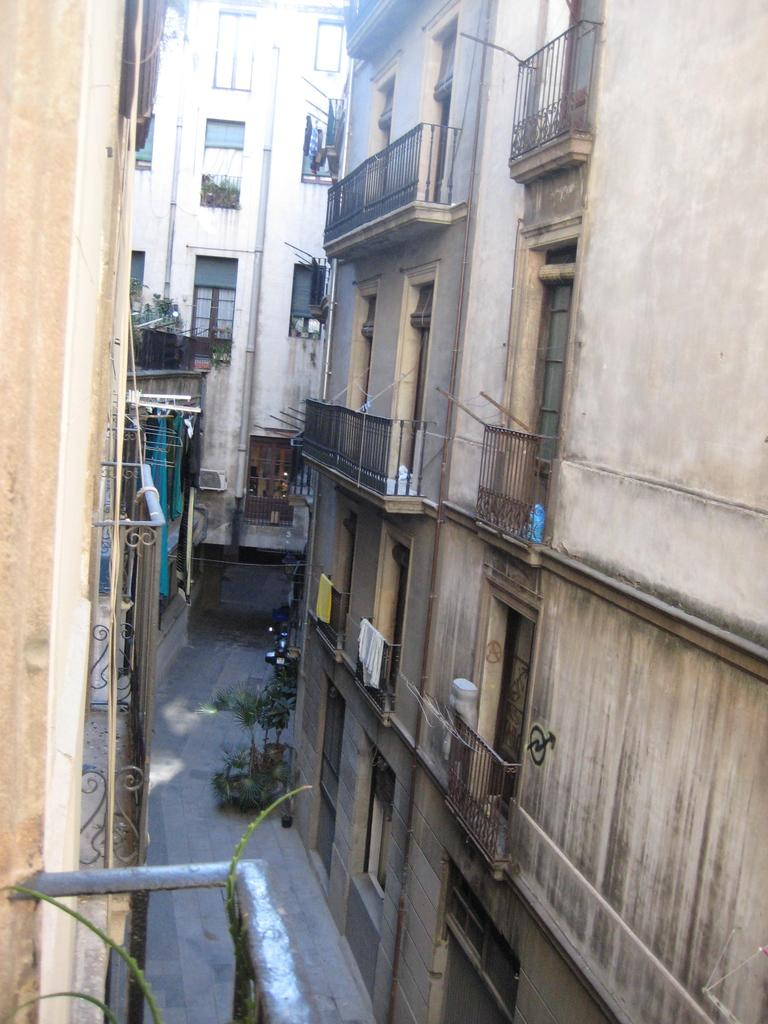What type of structures can be seen in the image? There are buildings in the image. What else is present in the image besides the buildings? There are plants and railings visible in the image. What feature can be found on the buildings in the image? Windows are present in the image. What word is written on the plants in the image? There are no words written on the plants in the image; they are simply plants. 